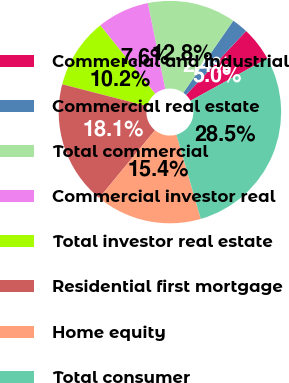Convert chart. <chart><loc_0><loc_0><loc_500><loc_500><pie_chart><fcel>Commercial and industrial<fcel>Commercial real estate<fcel>Total commercial<fcel>Commercial investor real<fcel>Total investor real estate<fcel>Residential first mortgage<fcel>Home equity<fcel>Total consumer<nl><fcel>4.98%<fcel>2.36%<fcel>12.83%<fcel>7.59%<fcel>10.21%<fcel>18.06%<fcel>15.44%<fcel>28.52%<nl></chart> 